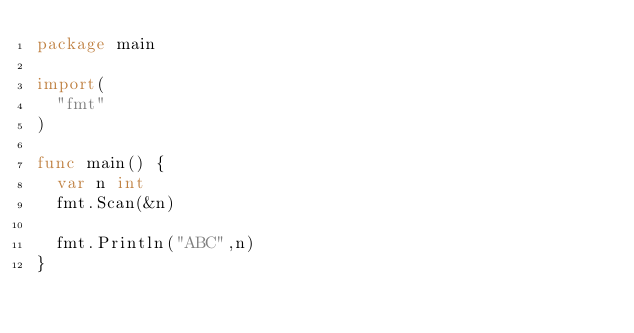<code> <loc_0><loc_0><loc_500><loc_500><_Go_>package main

import(
  "fmt"
)

func main() {
  var n int
  fmt.Scan(&n)
  
  fmt.Println("ABC",n)
}</code> 